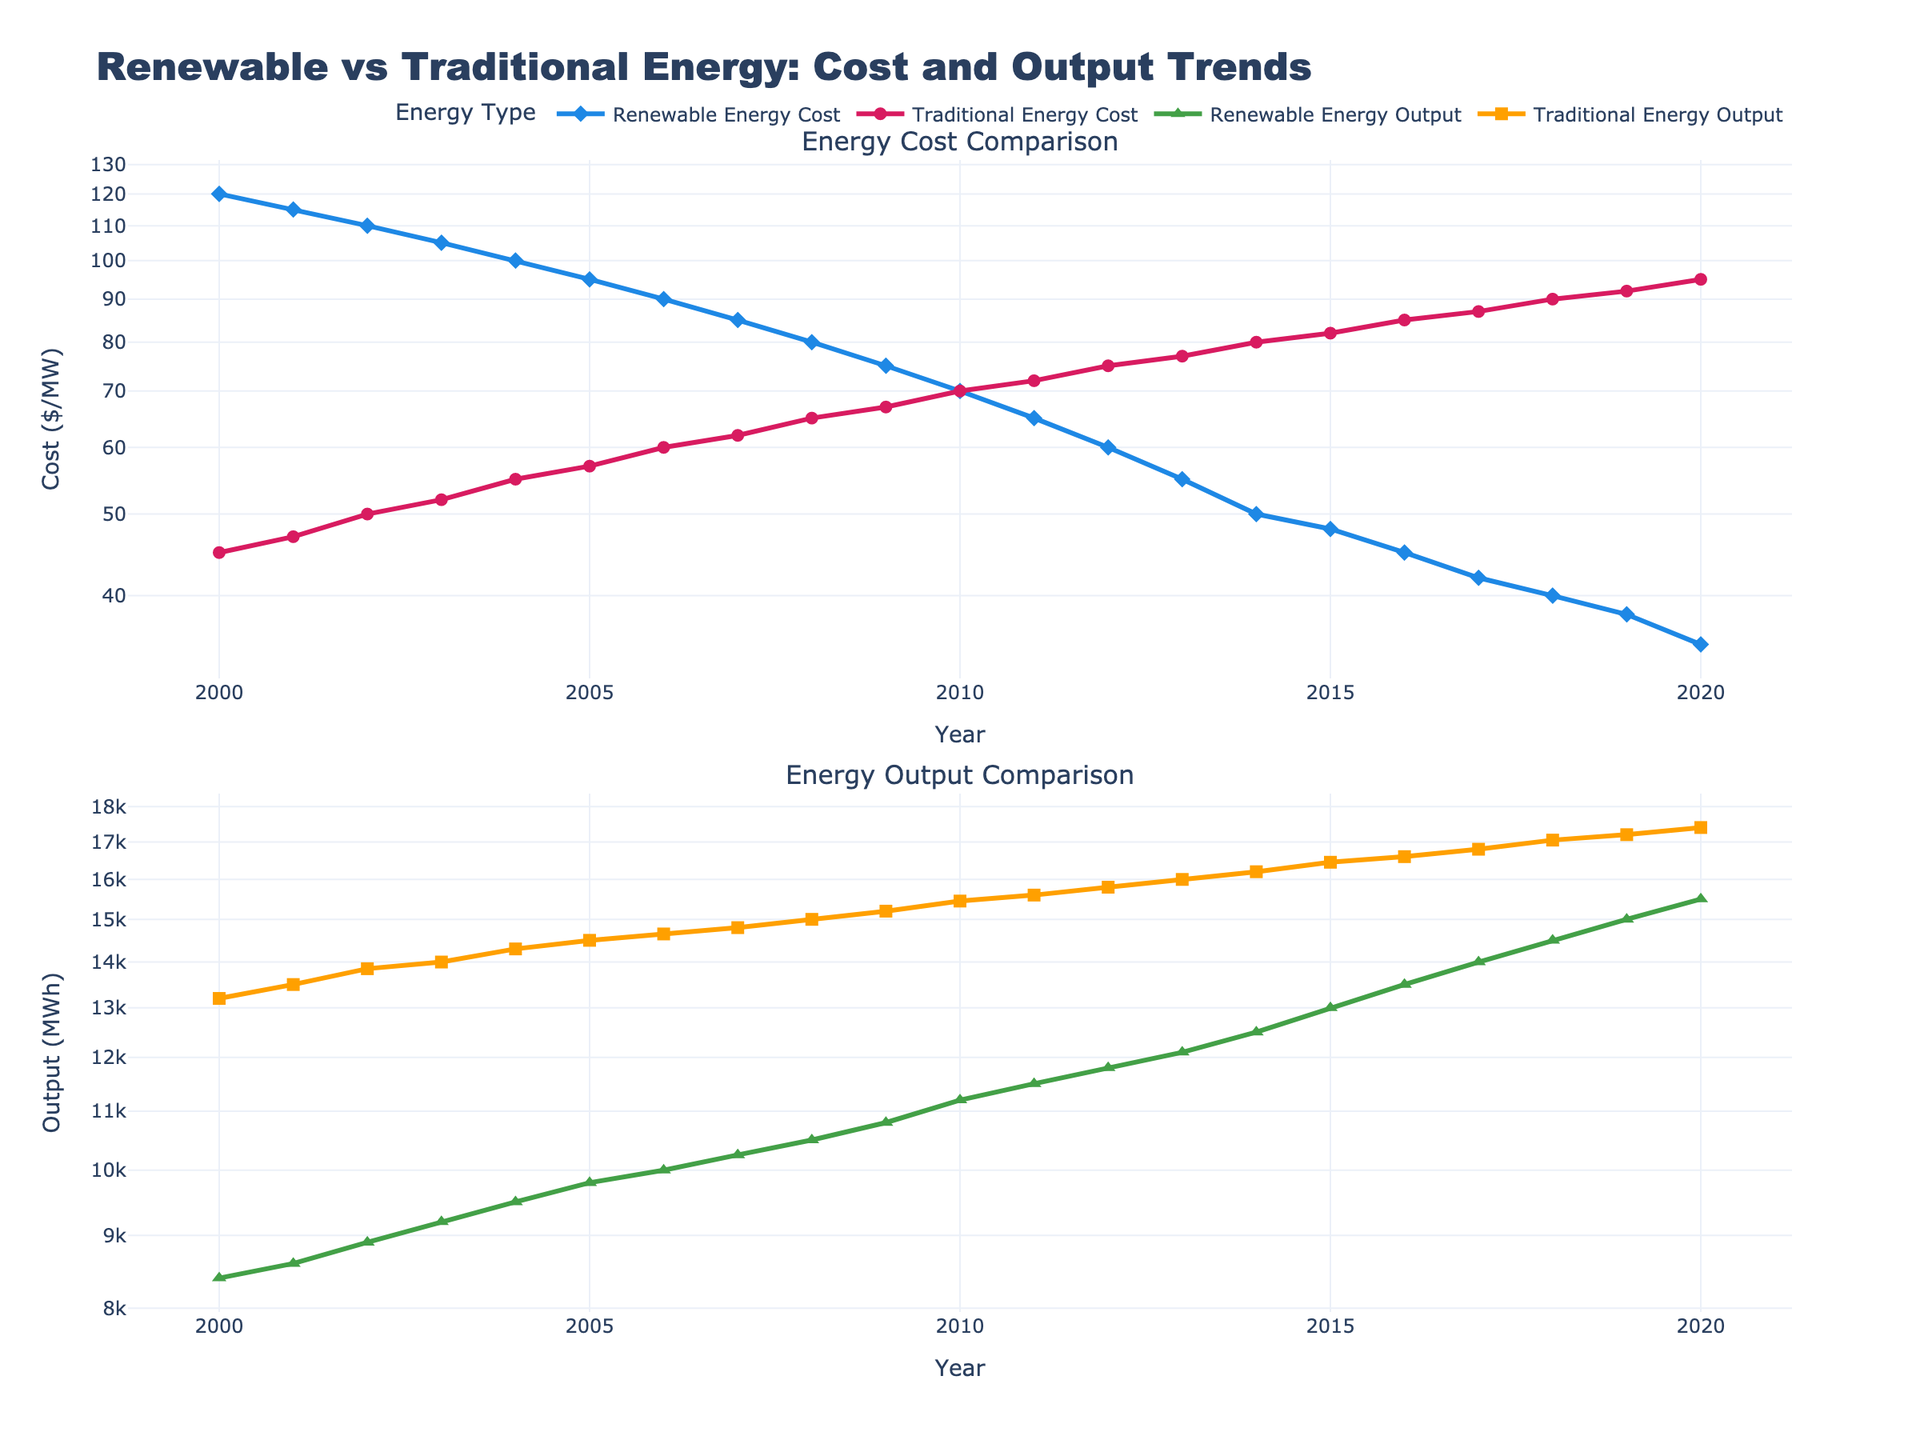What is the title of the first subplot? The title of the first subplot is labeled at the top of the first subplot area.
Answer: Energy Cost Comparison What is the trend in renewable energy costs from 2000 to 2020? To find the trend, observe the line plot for Renewable Energy Cost from 2000 to 2020 and note how the values change. The line shows a noticeable downward trend in the cost.
Answer: Decreasing In which year do renewable and traditional energy outputs first reach 14,000 MWh? To answer this, look for the years where both the renewable and traditional output lines reach 14,000 MWh on the Y-axis of the second subplot. Renewable energy reaches this in 2017, while traditional energy reaches it in 2003.
Answer: 2017 (Renewable), 2003 (Traditional) Compare the year 2010: Which energy source had a higher output, and by how much? For 2010, examine both energy outputs. The renewable output is 11,200 MWh, and the traditional output is 15,450 MWh. To find the difference: 15,450 - 11,200 = 4,250 MWh.
Answer: Traditional by 4,250 MWh What is the log scale Y-axis range for the "Energy Output Comparison" subplot? The log scale Y-axis for energy output comparison ranges from the smallest to the largest value on the scale. The output values on the Y-axis span from approximately 8,400 to 17,400 MWh.
Answer: Approximately 8,400 to 17,400 MWh Which energy source had a higher cost in the year 2005, and what was the difference? Check both the costs for the year 2005: Renewable Energy Cost is $95/MW, and Traditional Energy Cost is $57/MW. The difference is 95 - 57 = $38/MW.
Answer: Renewable by $38/MW Does the cost of traditional energy ever become cheaper than renewable energy over the years? To find this, check every year's comparison between the costs of renewable and traditional energy. At no point does the traditional energy cost become cheaper than renewable energy throughout the period.
Answer: No Which energy source shows a greater rate of decrease in cost per MW from 2000 to 2020? Observe the decline slopes of both energy sources' cost lines. The renewable energy cost line shows a steeper decline from ~$120/MW to ~$35/MW. Traditional energy cost declines from ~$45/MW to ~$95/MW. The greater reduction in renewable energy implies a steeper rate.
Answer: Renewable Energy What is the difference in traditional energy output between the year 2018 and 2002? Look at the second subplot for traditional output in 2018 (17,050 MWh) and 2002 (13,850 MWh). The difference is 17,050 - 13,850 = 3,200 MWh.
Answer: 3,200 MWh Did renewable energy ever surpass traditional energy in terms of output within the years 2000 to 2020? To check this, compare both the outputs year by year (second subplot). Traditional energy output remains higher than renewable energy output throughout the period.
Answer: No 